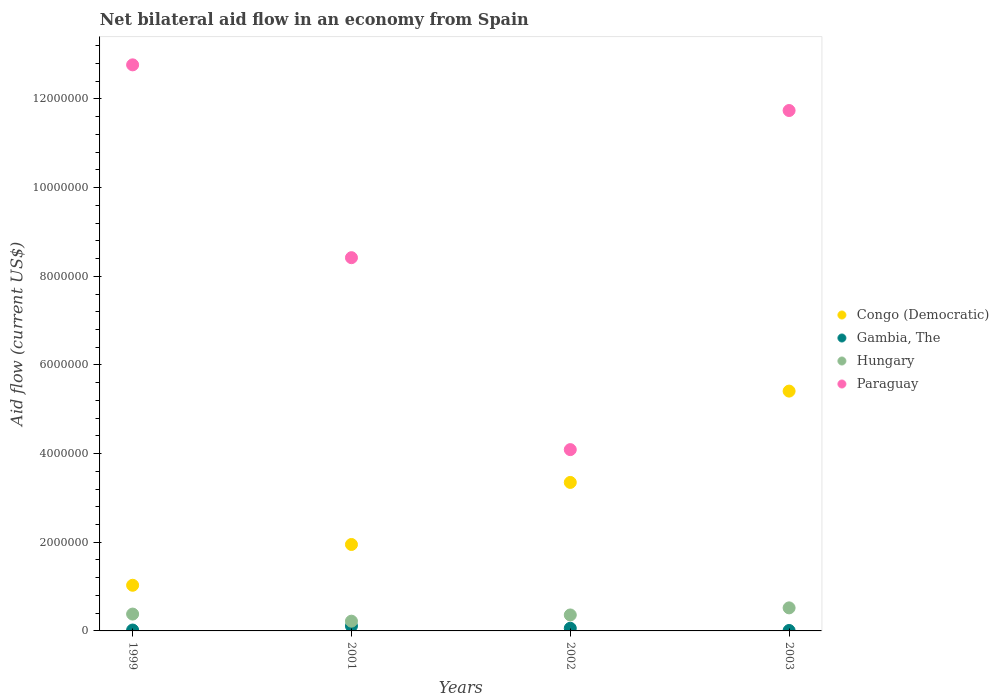How many different coloured dotlines are there?
Give a very brief answer. 4. Is the number of dotlines equal to the number of legend labels?
Give a very brief answer. Yes. Across all years, what is the maximum net bilateral aid flow in Paraguay?
Give a very brief answer. 1.28e+07. Across all years, what is the minimum net bilateral aid flow in Congo (Democratic)?
Your answer should be very brief. 1.03e+06. In which year was the net bilateral aid flow in Congo (Democratic) minimum?
Make the answer very short. 1999. What is the total net bilateral aid flow in Congo (Democratic) in the graph?
Make the answer very short. 1.17e+07. What is the difference between the net bilateral aid flow in Paraguay in 1999 and that in 2001?
Make the answer very short. 4.35e+06. What is the difference between the net bilateral aid flow in Paraguay in 2003 and the net bilateral aid flow in Gambia, The in 1999?
Give a very brief answer. 1.17e+07. What is the average net bilateral aid flow in Congo (Democratic) per year?
Provide a succinct answer. 2.94e+06. In the year 2001, what is the difference between the net bilateral aid flow in Congo (Democratic) and net bilateral aid flow in Gambia, The?
Give a very brief answer. 1.84e+06. What is the ratio of the net bilateral aid flow in Congo (Democratic) in 1999 to that in 2003?
Provide a short and direct response. 0.19. Is the net bilateral aid flow in Hungary in 2001 less than that in 2003?
Offer a very short reply. Yes. Is the difference between the net bilateral aid flow in Congo (Democratic) in 2002 and 2003 greater than the difference between the net bilateral aid flow in Gambia, The in 2002 and 2003?
Offer a very short reply. No. What is the difference between the highest and the second highest net bilateral aid flow in Congo (Democratic)?
Your response must be concise. 2.06e+06. Is it the case that in every year, the sum of the net bilateral aid flow in Paraguay and net bilateral aid flow in Congo (Democratic)  is greater than the sum of net bilateral aid flow in Hungary and net bilateral aid flow in Gambia, The?
Provide a succinct answer. Yes. Is it the case that in every year, the sum of the net bilateral aid flow in Hungary and net bilateral aid flow in Paraguay  is greater than the net bilateral aid flow in Gambia, The?
Make the answer very short. Yes. Does the net bilateral aid flow in Congo (Democratic) monotonically increase over the years?
Offer a terse response. Yes. Is the net bilateral aid flow in Paraguay strictly less than the net bilateral aid flow in Congo (Democratic) over the years?
Give a very brief answer. No. How many years are there in the graph?
Keep it short and to the point. 4. What is the difference between two consecutive major ticks on the Y-axis?
Offer a very short reply. 2.00e+06. Are the values on the major ticks of Y-axis written in scientific E-notation?
Offer a terse response. No. Does the graph contain any zero values?
Keep it short and to the point. No. Does the graph contain grids?
Your response must be concise. No. Where does the legend appear in the graph?
Provide a succinct answer. Center right. How many legend labels are there?
Your response must be concise. 4. What is the title of the graph?
Offer a very short reply. Net bilateral aid flow in an economy from Spain. What is the label or title of the Y-axis?
Ensure brevity in your answer.  Aid flow (current US$). What is the Aid flow (current US$) of Congo (Democratic) in 1999?
Offer a very short reply. 1.03e+06. What is the Aid flow (current US$) in Gambia, The in 1999?
Provide a short and direct response. 2.00e+04. What is the Aid flow (current US$) in Paraguay in 1999?
Provide a short and direct response. 1.28e+07. What is the Aid flow (current US$) of Congo (Democratic) in 2001?
Provide a short and direct response. 1.95e+06. What is the Aid flow (current US$) in Gambia, The in 2001?
Make the answer very short. 1.10e+05. What is the Aid flow (current US$) of Hungary in 2001?
Give a very brief answer. 2.20e+05. What is the Aid flow (current US$) in Paraguay in 2001?
Offer a terse response. 8.42e+06. What is the Aid flow (current US$) in Congo (Democratic) in 2002?
Your response must be concise. 3.35e+06. What is the Aid flow (current US$) in Hungary in 2002?
Keep it short and to the point. 3.60e+05. What is the Aid flow (current US$) of Paraguay in 2002?
Provide a short and direct response. 4.09e+06. What is the Aid flow (current US$) in Congo (Democratic) in 2003?
Make the answer very short. 5.41e+06. What is the Aid flow (current US$) of Gambia, The in 2003?
Offer a very short reply. 10000. What is the Aid flow (current US$) of Hungary in 2003?
Provide a succinct answer. 5.20e+05. What is the Aid flow (current US$) in Paraguay in 2003?
Your answer should be compact. 1.17e+07. Across all years, what is the maximum Aid flow (current US$) in Congo (Democratic)?
Your response must be concise. 5.41e+06. Across all years, what is the maximum Aid flow (current US$) in Hungary?
Your answer should be compact. 5.20e+05. Across all years, what is the maximum Aid flow (current US$) in Paraguay?
Your answer should be very brief. 1.28e+07. Across all years, what is the minimum Aid flow (current US$) in Congo (Democratic)?
Provide a succinct answer. 1.03e+06. Across all years, what is the minimum Aid flow (current US$) of Gambia, The?
Keep it short and to the point. 10000. Across all years, what is the minimum Aid flow (current US$) in Paraguay?
Your answer should be compact. 4.09e+06. What is the total Aid flow (current US$) in Congo (Democratic) in the graph?
Your answer should be compact. 1.17e+07. What is the total Aid flow (current US$) of Gambia, The in the graph?
Give a very brief answer. 2.00e+05. What is the total Aid flow (current US$) in Hungary in the graph?
Provide a succinct answer. 1.48e+06. What is the total Aid flow (current US$) in Paraguay in the graph?
Your response must be concise. 3.70e+07. What is the difference between the Aid flow (current US$) of Congo (Democratic) in 1999 and that in 2001?
Provide a succinct answer. -9.20e+05. What is the difference between the Aid flow (current US$) in Gambia, The in 1999 and that in 2001?
Offer a very short reply. -9.00e+04. What is the difference between the Aid flow (current US$) in Paraguay in 1999 and that in 2001?
Provide a succinct answer. 4.35e+06. What is the difference between the Aid flow (current US$) of Congo (Democratic) in 1999 and that in 2002?
Your answer should be compact. -2.32e+06. What is the difference between the Aid flow (current US$) in Gambia, The in 1999 and that in 2002?
Provide a short and direct response. -4.00e+04. What is the difference between the Aid flow (current US$) of Paraguay in 1999 and that in 2002?
Keep it short and to the point. 8.68e+06. What is the difference between the Aid flow (current US$) in Congo (Democratic) in 1999 and that in 2003?
Offer a very short reply. -4.38e+06. What is the difference between the Aid flow (current US$) in Hungary in 1999 and that in 2003?
Keep it short and to the point. -1.40e+05. What is the difference between the Aid flow (current US$) in Paraguay in 1999 and that in 2003?
Keep it short and to the point. 1.03e+06. What is the difference between the Aid flow (current US$) of Congo (Democratic) in 2001 and that in 2002?
Provide a short and direct response. -1.40e+06. What is the difference between the Aid flow (current US$) of Gambia, The in 2001 and that in 2002?
Keep it short and to the point. 5.00e+04. What is the difference between the Aid flow (current US$) of Hungary in 2001 and that in 2002?
Your answer should be very brief. -1.40e+05. What is the difference between the Aid flow (current US$) of Paraguay in 2001 and that in 2002?
Your response must be concise. 4.33e+06. What is the difference between the Aid flow (current US$) in Congo (Democratic) in 2001 and that in 2003?
Your response must be concise. -3.46e+06. What is the difference between the Aid flow (current US$) in Paraguay in 2001 and that in 2003?
Make the answer very short. -3.32e+06. What is the difference between the Aid flow (current US$) of Congo (Democratic) in 2002 and that in 2003?
Provide a short and direct response. -2.06e+06. What is the difference between the Aid flow (current US$) of Gambia, The in 2002 and that in 2003?
Your answer should be very brief. 5.00e+04. What is the difference between the Aid flow (current US$) of Hungary in 2002 and that in 2003?
Provide a succinct answer. -1.60e+05. What is the difference between the Aid flow (current US$) of Paraguay in 2002 and that in 2003?
Your answer should be very brief. -7.65e+06. What is the difference between the Aid flow (current US$) of Congo (Democratic) in 1999 and the Aid flow (current US$) of Gambia, The in 2001?
Your answer should be very brief. 9.20e+05. What is the difference between the Aid flow (current US$) in Congo (Democratic) in 1999 and the Aid flow (current US$) in Hungary in 2001?
Give a very brief answer. 8.10e+05. What is the difference between the Aid flow (current US$) in Congo (Democratic) in 1999 and the Aid flow (current US$) in Paraguay in 2001?
Your answer should be very brief. -7.39e+06. What is the difference between the Aid flow (current US$) in Gambia, The in 1999 and the Aid flow (current US$) in Hungary in 2001?
Your answer should be compact. -2.00e+05. What is the difference between the Aid flow (current US$) in Gambia, The in 1999 and the Aid flow (current US$) in Paraguay in 2001?
Keep it short and to the point. -8.40e+06. What is the difference between the Aid flow (current US$) in Hungary in 1999 and the Aid flow (current US$) in Paraguay in 2001?
Offer a terse response. -8.04e+06. What is the difference between the Aid flow (current US$) in Congo (Democratic) in 1999 and the Aid flow (current US$) in Gambia, The in 2002?
Make the answer very short. 9.70e+05. What is the difference between the Aid flow (current US$) in Congo (Democratic) in 1999 and the Aid flow (current US$) in Hungary in 2002?
Your answer should be compact. 6.70e+05. What is the difference between the Aid flow (current US$) in Congo (Democratic) in 1999 and the Aid flow (current US$) in Paraguay in 2002?
Give a very brief answer. -3.06e+06. What is the difference between the Aid flow (current US$) in Gambia, The in 1999 and the Aid flow (current US$) in Hungary in 2002?
Make the answer very short. -3.40e+05. What is the difference between the Aid flow (current US$) of Gambia, The in 1999 and the Aid flow (current US$) of Paraguay in 2002?
Provide a short and direct response. -4.07e+06. What is the difference between the Aid flow (current US$) in Hungary in 1999 and the Aid flow (current US$) in Paraguay in 2002?
Provide a succinct answer. -3.71e+06. What is the difference between the Aid flow (current US$) of Congo (Democratic) in 1999 and the Aid flow (current US$) of Gambia, The in 2003?
Make the answer very short. 1.02e+06. What is the difference between the Aid flow (current US$) of Congo (Democratic) in 1999 and the Aid flow (current US$) of Hungary in 2003?
Offer a terse response. 5.10e+05. What is the difference between the Aid flow (current US$) in Congo (Democratic) in 1999 and the Aid flow (current US$) in Paraguay in 2003?
Ensure brevity in your answer.  -1.07e+07. What is the difference between the Aid flow (current US$) in Gambia, The in 1999 and the Aid flow (current US$) in Hungary in 2003?
Your answer should be very brief. -5.00e+05. What is the difference between the Aid flow (current US$) in Gambia, The in 1999 and the Aid flow (current US$) in Paraguay in 2003?
Give a very brief answer. -1.17e+07. What is the difference between the Aid flow (current US$) in Hungary in 1999 and the Aid flow (current US$) in Paraguay in 2003?
Offer a very short reply. -1.14e+07. What is the difference between the Aid flow (current US$) in Congo (Democratic) in 2001 and the Aid flow (current US$) in Gambia, The in 2002?
Keep it short and to the point. 1.89e+06. What is the difference between the Aid flow (current US$) in Congo (Democratic) in 2001 and the Aid flow (current US$) in Hungary in 2002?
Your answer should be very brief. 1.59e+06. What is the difference between the Aid flow (current US$) of Congo (Democratic) in 2001 and the Aid flow (current US$) of Paraguay in 2002?
Your answer should be very brief. -2.14e+06. What is the difference between the Aid flow (current US$) of Gambia, The in 2001 and the Aid flow (current US$) of Paraguay in 2002?
Provide a short and direct response. -3.98e+06. What is the difference between the Aid flow (current US$) of Hungary in 2001 and the Aid flow (current US$) of Paraguay in 2002?
Provide a succinct answer. -3.87e+06. What is the difference between the Aid flow (current US$) in Congo (Democratic) in 2001 and the Aid flow (current US$) in Gambia, The in 2003?
Ensure brevity in your answer.  1.94e+06. What is the difference between the Aid flow (current US$) in Congo (Democratic) in 2001 and the Aid flow (current US$) in Hungary in 2003?
Ensure brevity in your answer.  1.43e+06. What is the difference between the Aid flow (current US$) in Congo (Democratic) in 2001 and the Aid flow (current US$) in Paraguay in 2003?
Offer a very short reply. -9.79e+06. What is the difference between the Aid flow (current US$) of Gambia, The in 2001 and the Aid flow (current US$) of Hungary in 2003?
Keep it short and to the point. -4.10e+05. What is the difference between the Aid flow (current US$) in Gambia, The in 2001 and the Aid flow (current US$) in Paraguay in 2003?
Provide a succinct answer. -1.16e+07. What is the difference between the Aid flow (current US$) of Hungary in 2001 and the Aid flow (current US$) of Paraguay in 2003?
Ensure brevity in your answer.  -1.15e+07. What is the difference between the Aid flow (current US$) in Congo (Democratic) in 2002 and the Aid flow (current US$) in Gambia, The in 2003?
Your answer should be very brief. 3.34e+06. What is the difference between the Aid flow (current US$) in Congo (Democratic) in 2002 and the Aid flow (current US$) in Hungary in 2003?
Offer a terse response. 2.83e+06. What is the difference between the Aid flow (current US$) in Congo (Democratic) in 2002 and the Aid flow (current US$) in Paraguay in 2003?
Provide a succinct answer. -8.39e+06. What is the difference between the Aid flow (current US$) in Gambia, The in 2002 and the Aid flow (current US$) in Hungary in 2003?
Your response must be concise. -4.60e+05. What is the difference between the Aid flow (current US$) in Gambia, The in 2002 and the Aid flow (current US$) in Paraguay in 2003?
Your response must be concise. -1.17e+07. What is the difference between the Aid flow (current US$) in Hungary in 2002 and the Aid flow (current US$) in Paraguay in 2003?
Your answer should be very brief. -1.14e+07. What is the average Aid flow (current US$) of Congo (Democratic) per year?
Your answer should be compact. 2.94e+06. What is the average Aid flow (current US$) in Gambia, The per year?
Provide a succinct answer. 5.00e+04. What is the average Aid flow (current US$) of Hungary per year?
Provide a succinct answer. 3.70e+05. What is the average Aid flow (current US$) of Paraguay per year?
Offer a terse response. 9.26e+06. In the year 1999, what is the difference between the Aid flow (current US$) of Congo (Democratic) and Aid flow (current US$) of Gambia, The?
Your answer should be compact. 1.01e+06. In the year 1999, what is the difference between the Aid flow (current US$) in Congo (Democratic) and Aid flow (current US$) in Hungary?
Offer a very short reply. 6.50e+05. In the year 1999, what is the difference between the Aid flow (current US$) in Congo (Democratic) and Aid flow (current US$) in Paraguay?
Offer a very short reply. -1.17e+07. In the year 1999, what is the difference between the Aid flow (current US$) of Gambia, The and Aid flow (current US$) of Hungary?
Your answer should be very brief. -3.60e+05. In the year 1999, what is the difference between the Aid flow (current US$) in Gambia, The and Aid flow (current US$) in Paraguay?
Your response must be concise. -1.28e+07. In the year 1999, what is the difference between the Aid flow (current US$) of Hungary and Aid flow (current US$) of Paraguay?
Give a very brief answer. -1.24e+07. In the year 2001, what is the difference between the Aid flow (current US$) in Congo (Democratic) and Aid flow (current US$) in Gambia, The?
Your answer should be compact. 1.84e+06. In the year 2001, what is the difference between the Aid flow (current US$) of Congo (Democratic) and Aid flow (current US$) of Hungary?
Keep it short and to the point. 1.73e+06. In the year 2001, what is the difference between the Aid flow (current US$) of Congo (Democratic) and Aid flow (current US$) of Paraguay?
Make the answer very short. -6.47e+06. In the year 2001, what is the difference between the Aid flow (current US$) in Gambia, The and Aid flow (current US$) in Hungary?
Offer a very short reply. -1.10e+05. In the year 2001, what is the difference between the Aid flow (current US$) in Gambia, The and Aid flow (current US$) in Paraguay?
Make the answer very short. -8.31e+06. In the year 2001, what is the difference between the Aid flow (current US$) in Hungary and Aid flow (current US$) in Paraguay?
Ensure brevity in your answer.  -8.20e+06. In the year 2002, what is the difference between the Aid flow (current US$) of Congo (Democratic) and Aid flow (current US$) of Gambia, The?
Offer a very short reply. 3.29e+06. In the year 2002, what is the difference between the Aid flow (current US$) in Congo (Democratic) and Aid flow (current US$) in Hungary?
Make the answer very short. 2.99e+06. In the year 2002, what is the difference between the Aid flow (current US$) in Congo (Democratic) and Aid flow (current US$) in Paraguay?
Ensure brevity in your answer.  -7.40e+05. In the year 2002, what is the difference between the Aid flow (current US$) in Gambia, The and Aid flow (current US$) in Hungary?
Your answer should be very brief. -3.00e+05. In the year 2002, what is the difference between the Aid flow (current US$) of Gambia, The and Aid flow (current US$) of Paraguay?
Offer a terse response. -4.03e+06. In the year 2002, what is the difference between the Aid flow (current US$) of Hungary and Aid flow (current US$) of Paraguay?
Offer a very short reply. -3.73e+06. In the year 2003, what is the difference between the Aid flow (current US$) in Congo (Democratic) and Aid flow (current US$) in Gambia, The?
Keep it short and to the point. 5.40e+06. In the year 2003, what is the difference between the Aid flow (current US$) of Congo (Democratic) and Aid flow (current US$) of Hungary?
Your answer should be compact. 4.89e+06. In the year 2003, what is the difference between the Aid flow (current US$) of Congo (Democratic) and Aid flow (current US$) of Paraguay?
Your answer should be compact. -6.33e+06. In the year 2003, what is the difference between the Aid flow (current US$) in Gambia, The and Aid flow (current US$) in Hungary?
Your answer should be very brief. -5.10e+05. In the year 2003, what is the difference between the Aid flow (current US$) of Gambia, The and Aid flow (current US$) of Paraguay?
Ensure brevity in your answer.  -1.17e+07. In the year 2003, what is the difference between the Aid flow (current US$) in Hungary and Aid flow (current US$) in Paraguay?
Offer a very short reply. -1.12e+07. What is the ratio of the Aid flow (current US$) of Congo (Democratic) in 1999 to that in 2001?
Your response must be concise. 0.53. What is the ratio of the Aid flow (current US$) of Gambia, The in 1999 to that in 2001?
Offer a very short reply. 0.18. What is the ratio of the Aid flow (current US$) of Hungary in 1999 to that in 2001?
Make the answer very short. 1.73. What is the ratio of the Aid flow (current US$) in Paraguay in 1999 to that in 2001?
Offer a terse response. 1.52. What is the ratio of the Aid flow (current US$) of Congo (Democratic) in 1999 to that in 2002?
Offer a very short reply. 0.31. What is the ratio of the Aid flow (current US$) of Gambia, The in 1999 to that in 2002?
Ensure brevity in your answer.  0.33. What is the ratio of the Aid flow (current US$) of Hungary in 1999 to that in 2002?
Offer a terse response. 1.06. What is the ratio of the Aid flow (current US$) of Paraguay in 1999 to that in 2002?
Make the answer very short. 3.12. What is the ratio of the Aid flow (current US$) in Congo (Democratic) in 1999 to that in 2003?
Ensure brevity in your answer.  0.19. What is the ratio of the Aid flow (current US$) of Hungary in 1999 to that in 2003?
Your answer should be very brief. 0.73. What is the ratio of the Aid flow (current US$) of Paraguay in 1999 to that in 2003?
Offer a very short reply. 1.09. What is the ratio of the Aid flow (current US$) in Congo (Democratic) in 2001 to that in 2002?
Ensure brevity in your answer.  0.58. What is the ratio of the Aid flow (current US$) in Gambia, The in 2001 to that in 2002?
Give a very brief answer. 1.83. What is the ratio of the Aid flow (current US$) of Hungary in 2001 to that in 2002?
Offer a terse response. 0.61. What is the ratio of the Aid flow (current US$) in Paraguay in 2001 to that in 2002?
Give a very brief answer. 2.06. What is the ratio of the Aid flow (current US$) of Congo (Democratic) in 2001 to that in 2003?
Give a very brief answer. 0.36. What is the ratio of the Aid flow (current US$) in Hungary in 2001 to that in 2003?
Offer a very short reply. 0.42. What is the ratio of the Aid flow (current US$) of Paraguay in 2001 to that in 2003?
Give a very brief answer. 0.72. What is the ratio of the Aid flow (current US$) of Congo (Democratic) in 2002 to that in 2003?
Offer a terse response. 0.62. What is the ratio of the Aid flow (current US$) of Gambia, The in 2002 to that in 2003?
Your answer should be very brief. 6. What is the ratio of the Aid flow (current US$) in Hungary in 2002 to that in 2003?
Ensure brevity in your answer.  0.69. What is the ratio of the Aid flow (current US$) of Paraguay in 2002 to that in 2003?
Provide a short and direct response. 0.35. What is the difference between the highest and the second highest Aid flow (current US$) in Congo (Democratic)?
Make the answer very short. 2.06e+06. What is the difference between the highest and the second highest Aid flow (current US$) in Gambia, The?
Make the answer very short. 5.00e+04. What is the difference between the highest and the second highest Aid flow (current US$) of Hungary?
Give a very brief answer. 1.40e+05. What is the difference between the highest and the second highest Aid flow (current US$) of Paraguay?
Keep it short and to the point. 1.03e+06. What is the difference between the highest and the lowest Aid flow (current US$) of Congo (Democratic)?
Your answer should be compact. 4.38e+06. What is the difference between the highest and the lowest Aid flow (current US$) in Gambia, The?
Offer a very short reply. 1.00e+05. What is the difference between the highest and the lowest Aid flow (current US$) in Hungary?
Give a very brief answer. 3.00e+05. What is the difference between the highest and the lowest Aid flow (current US$) of Paraguay?
Ensure brevity in your answer.  8.68e+06. 